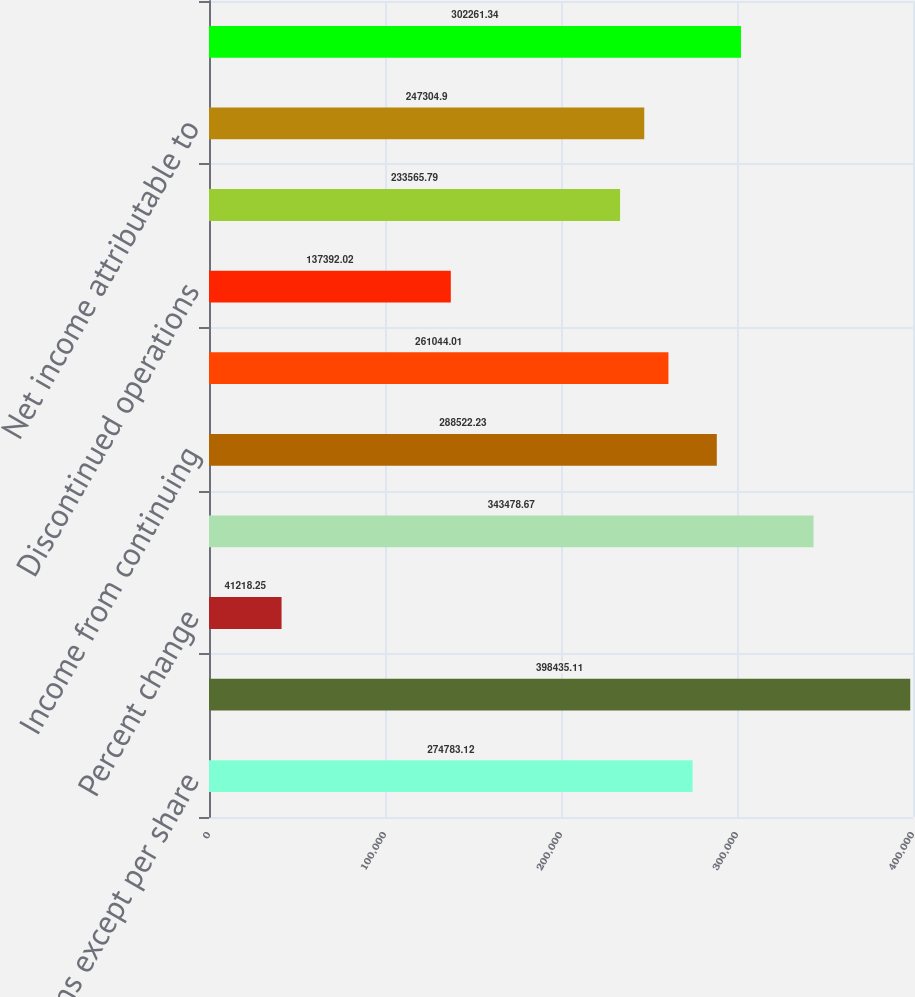Convert chart to OTSL. <chart><loc_0><loc_0><loc_500><loc_500><bar_chart><fcel>(In millions except per share<fcel>Revenues<fcel>Percent change<fcel>Gross profit<fcel>Income from continuing<fcel>Continuing operations (2)<fcel>Discontinued operations<fcel>Net income<fcel>Net income attributable to<fcel>Working capital<nl><fcel>274783<fcel>398435<fcel>41218.2<fcel>343479<fcel>288522<fcel>261044<fcel>137392<fcel>233566<fcel>247305<fcel>302261<nl></chart> 